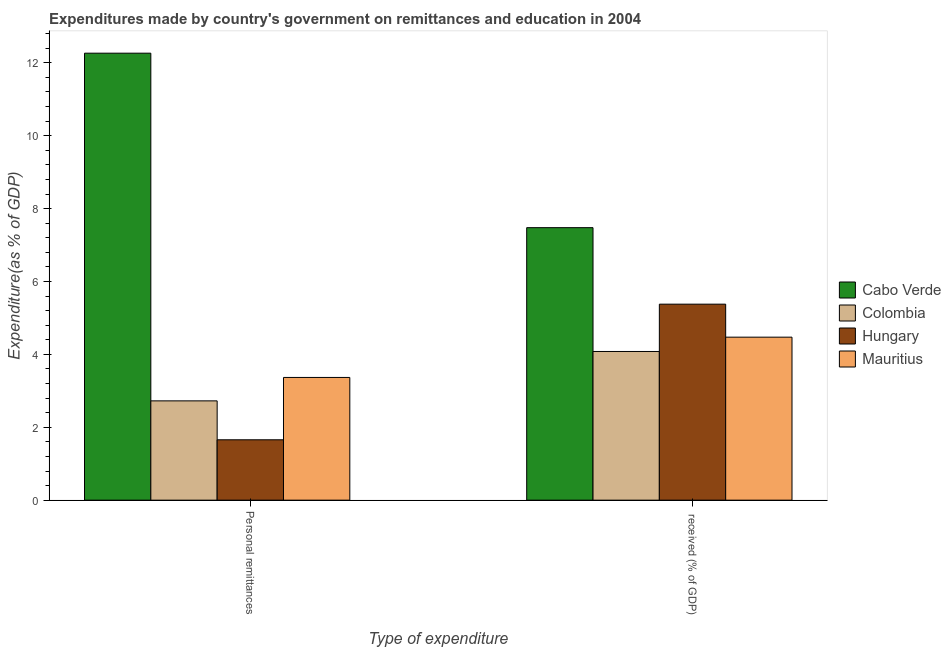How many different coloured bars are there?
Ensure brevity in your answer.  4. How many groups of bars are there?
Provide a succinct answer. 2. How many bars are there on the 1st tick from the left?
Your answer should be compact. 4. What is the label of the 2nd group of bars from the left?
Provide a succinct answer.  received (% of GDP). What is the expenditure in education in Hungary?
Your answer should be compact. 5.38. Across all countries, what is the maximum expenditure in education?
Provide a succinct answer. 7.48. Across all countries, what is the minimum expenditure in personal remittances?
Give a very brief answer. 1.66. In which country was the expenditure in education maximum?
Provide a short and direct response. Cabo Verde. In which country was the expenditure in personal remittances minimum?
Your answer should be very brief. Hungary. What is the total expenditure in education in the graph?
Provide a short and direct response. 21.41. What is the difference between the expenditure in education in Cabo Verde and that in Hungary?
Your response must be concise. 2.1. What is the difference between the expenditure in personal remittances in Hungary and the expenditure in education in Cabo Verde?
Provide a succinct answer. -5.82. What is the average expenditure in education per country?
Your answer should be compact. 5.35. What is the difference between the expenditure in education and expenditure in personal remittances in Hungary?
Keep it short and to the point. 3.72. What is the ratio of the expenditure in education in Colombia to that in Mauritius?
Make the answer very short. 0.91. Is the expenditure in education in Hungary less than that in Mauritius?
Your response must be concise. No. In how many countries, is the expenditure in education greater than the average expenditure in education taken over all countries?
Your answer should be very brief. 2. What does the 3rd bar from the left in  received (% of GDP) represents?
Provide a short and direct response. Hungary. What does the 4th bar from the right in Personal remittances represents?
Offer a very short reply. Cabo Verde. Are the values on the major ticks of Y-axis written in scientific E-notation?
Give a very brief answer. No. Does the graph contain grids?
Make the answer very short. No. What is the title of the graph?
Offer a very short reply. Expenditures made by country's government on remittances and education in 2004. Does "India" appear as one of the legend labels in the graph?
Give a very brief answer. No. What is the label or title of the X-axis?
Provide a succinct answer. Type of expenditure. What is the label or title of the Y-axis?
Ensure brevity in your answer.  Expenditure(as % of GDP). What is the Expenditure(as % of GDP) of Cabo Verde in Personal remittances?
Your answer should be compact. 12.26. What is the Expenditure(as % of GDP) of Colombia in Personal remittances?
Your answer should be compact. 2.72. What is the Expenditure(as % of GDP) in Hungary in Personal remittances?
Provide a succinct answer. 1.66. What is the Expenditure(as % of GDP) in Mauritius in Personal remittances?
Your answer should be compact. 3.37. What is the Expenditure(as % of GDP) of Cabo Verde in  received (% of GDP)?
Ensure brevity in your answer.  7.48. What is the Expenditure(as % of GDP) in Colombia in  received (% of GDP)?
Your response must be concise. 4.08. What is the Expenditure(as % of GDP) in Hungary in  received (% of GDP)?
Your answer should be compact. 5.38. What is the Expenditure(as % of GDP) of Mauritius in  received (% of GDP)?
Make the answer very short. 4.47. Across all Type of expenditure, what is the maximum Expenditure(as % of GDP) in Cabo Verde?
Your answer should be very brief. 12.26. Across all Type of expenditure, what is the maximum Expenditure(as % of GDP) of Colombia?
Provide a succinct answer. 4.08. Across all Type of expenditure, what is the maximum Expenditure(as % of GDP) of Hungary?
Your answer should be very brief. 5.38. Across all Type of expenditure, what is the maximum Expenditure(as % of GDP) of Mauritius?
Ensure brevity in your answer.  4.47. Across all Type of expenditure, what is the minimum Expenditure(as % of GDP) of Cabo Verde?
Keep it short and to the point. 7.48. Across all Type of expenditure, what is the minimum Expenditure(as % of GDP) of Colombia?
Keep it short and to the point. 2.72. Across all Type of expenditure, what is the minimum Expenditure(as % of GDP) in Hungary?
Your answer should be very brief. 1.66. Across all Type of expenditure, what is the minimum Expenditure(as % of GDP) in Mauritius?
Offer a very short reply. 3.37. What is the total Expenditure(as % of GDP) of Cabo Verde in the graph?
Make the answer very short. 19.74. What is the total Expenditure(as % of GDP) in Colombia in the graph?
Offer a very short reply. 6.8. What is the total Expenditure(as % of GDP) in Hungary in the graph?
Offer a very short reply. 7.03. What is the total Expenditure(as % of GDP) of Mauritius in the graph?
Your answer should be very brief. 7.84. What is the difference between the Expenditure(as % of GDP) in Cabo Verde in Personal remittances and that in  received (% of GDP)?
Your answer should be very brief. 4.79. What is the difference between the Expenditure(as % of GDP) in Colombia in Personal remittances and that in  received (% of GDP)?
Your answer should be very brief. -1.35. What is the difference between the Expenditure(as % of GDP) of Hungary in Personal remittances and that in  received (% of GDP)?
Your answer should be very brief. -3.72. What is the difference between the Expenditure(as % of GDP) in Mauritius in Personal remittances and that in  received (% of GDP)?
Keep it short and to the point. -1.11. What is the difference between the Expenditure(as % of GDP) in Cabo Verde in Personal remittances and the Expenditure(as % of GDP) in Colombia in  received (% of GDP)?
Offer a very short reply. 8.18. What is the difference between the Expenditure(as % of GDP) in Cabo Verde in Personal remittances and the Expenditure(as % of GDP) in Hungary in  received (% of GDP)?
Your response must be concise. 6.89. What is the difference between the Expenditure(as % of GDP) of Cabo Verde in Personal remittances and the Expenditure(as % of GDP) of Mauritius in  received (% of GDP)?
Ensure brevity in your answer.  7.79. What is the difference between the Expenditure(as % of GDP) in Colombia in Personal remittances and the Expenditure(as % of GDP) in Hungary in  received (% of GDP)?
Your response must be concise. -2.65. What is the difference between the Expenditure(as % of GDP) in Colombia in Personal remittances and the Expenditure(as % of GDP) in Mauritius in  received (% of GDP)?
Give a very brief answer. -1.75. What is the difference between the Expenditure(as % of GDP) in Hungary in Personal remittances and the Expenditure(as % of GDP) in Mauritius in  received (% of GDP)?
Make the answer very short. -2.82. What is the average Expenditure(as % of GDP) in Cabo Verde per Type of expenditure?
Your answer should be compact. 9.87. What is the average Expenditure(as % of GDP) in Colombia per Type of expenditure?
Provide a succinct answer. 3.4. What is the average Expenditure(as % of GDP) of Hungary per Type of expenditure?
Give a very brief answer. 3.52. What is the average Expenditure(as % of GDP) in Mauritius per Type of expenditure?
Ensure brevity in your answer.  3.92. What is the difference between the Expenditure(as % of GDP) in Cabo Verde and Expenditure(as % of GDP) in Colombia in Personal remittances?
Your answer should be very brief. 9.54. What is the difference between the Expenditure(as % of GDP) of Cabo Verde and Expenditure(as % of GDP) of Hungary in Personal remittances?
Offer a terse response. 10.61. What is the difference between the Expenditure(as % of GDP) of Cabo Verde and Expenditure(as % of GDP) of Mauritius in Personal remittances?
Provide a succinct answer. 8.9. What is the difference between the Expenditure(as % of GDP) in Colombia and Expenditure(as % of GDP) in Hungary in Personal remittances?
Give a very brief answer. 1.07. What is the difference between the Expenditure(as % of GDP) of Colombia and Expenditure(as % of GDP) of Mauritius in Personal remittances?
Your answer should be very brief. -0.64. What is the difference between the Expenditure(as % of GDP) in Hungary and Expenditure(as % of GDP) in Mauritius in Personal remittances?
Ensure brevity in your answer.  -1.71. What is the difference between the Expenditure(as % of GDP) of Cabo Verde and Expenditure(as % of GDP) of Colombia in  received (% of GDP)?
Ensure brevity in your answer.  3.4. What is the difference between the Expenditure(as % of GDP) of Cabo Verde and Expenditure(as % of GDP) of Hungary in  received (% of GDP)?
Offer a terse response. 2.1. What is the difference between the Expenditure(as % of GDP) of Cabo Verde and Expenditure(as % of GDP) of Mauritius in  received (% of GDP)?
Keep it short and to the point. 3. What is the difference between the Expenditure(as % of GDP) in Colombia and Expenditure(as % of GDP) in Hungary in  received (% of GDP)?
Keep it short and to the point. -1.3. What is the difference between the Expenditure(as % of GDP) of Colombia and Expenditure(as % of GDP) of Mauritius in  received (% of GDP)?
Keep it short and to the point. -0.39. What is the difference between the Expenditure(as % of GDP) in Hungary and Expenditure(as % of GDP) in Mauritius in  received (% of GDP)?
Your answer should be very brief. 0.91. What is the ratio of the Expenditure(as % of GDP) in Cabo Verde in Personal remittances to that in  received (% of GDP)?
Make the answer very short. 1.64. What is the ratio of the Expenditure(as % of GDP) of Colombia in Personal remittances to that in  received (% of GDP)?
Your response must be concise. 0.67. What is the ratio of the Expenditure(as % of GDP) of Hungary in Personal remittances to that in  received (% of GDP)?
Offer a very short reply. 0.31. What is the ratio of the Expenditure(as % of GDP) in Mauritius in Personal remittances to that in  received (% of GDP)?
Make the answer very short. 0.75. What is the difference between the highest and the second highest Expenditure(as % of GDP) of Cabo Verde?
Offer a terse response. 4.79. What is the difference between the highest and the second highest Expenditure(as % of GDP) in Colombia?
Offer a very short reply. 1.35. What is the difference between the highest and the second highest Expenditure(as % of GDP) of Hungary?
Offer a terse response. 3.72. What is the difference between the highest and the second highest Expenditure(as % of GDP) in Mauritius?
Your answer should be very brief. 1.11. What is the difference between the highest and the lowest Expenditure(as % of GDP) of Cabo Verde?
Keep it short and to the point. 4.79. What is the difference between the highest and the lowest Expenditure(as % of GDP) in Colombia?
Offer a very short reply. 1.35. What is the difference between the highest and the lowest Expenditure(as % of GDP) of Hungary?
Provide a short and direct response. 3.72. What is the difference between the highest and the lowest Expenditure(as % of GDP) of Mauritius?
Provide a short and direct response. 1.11. 